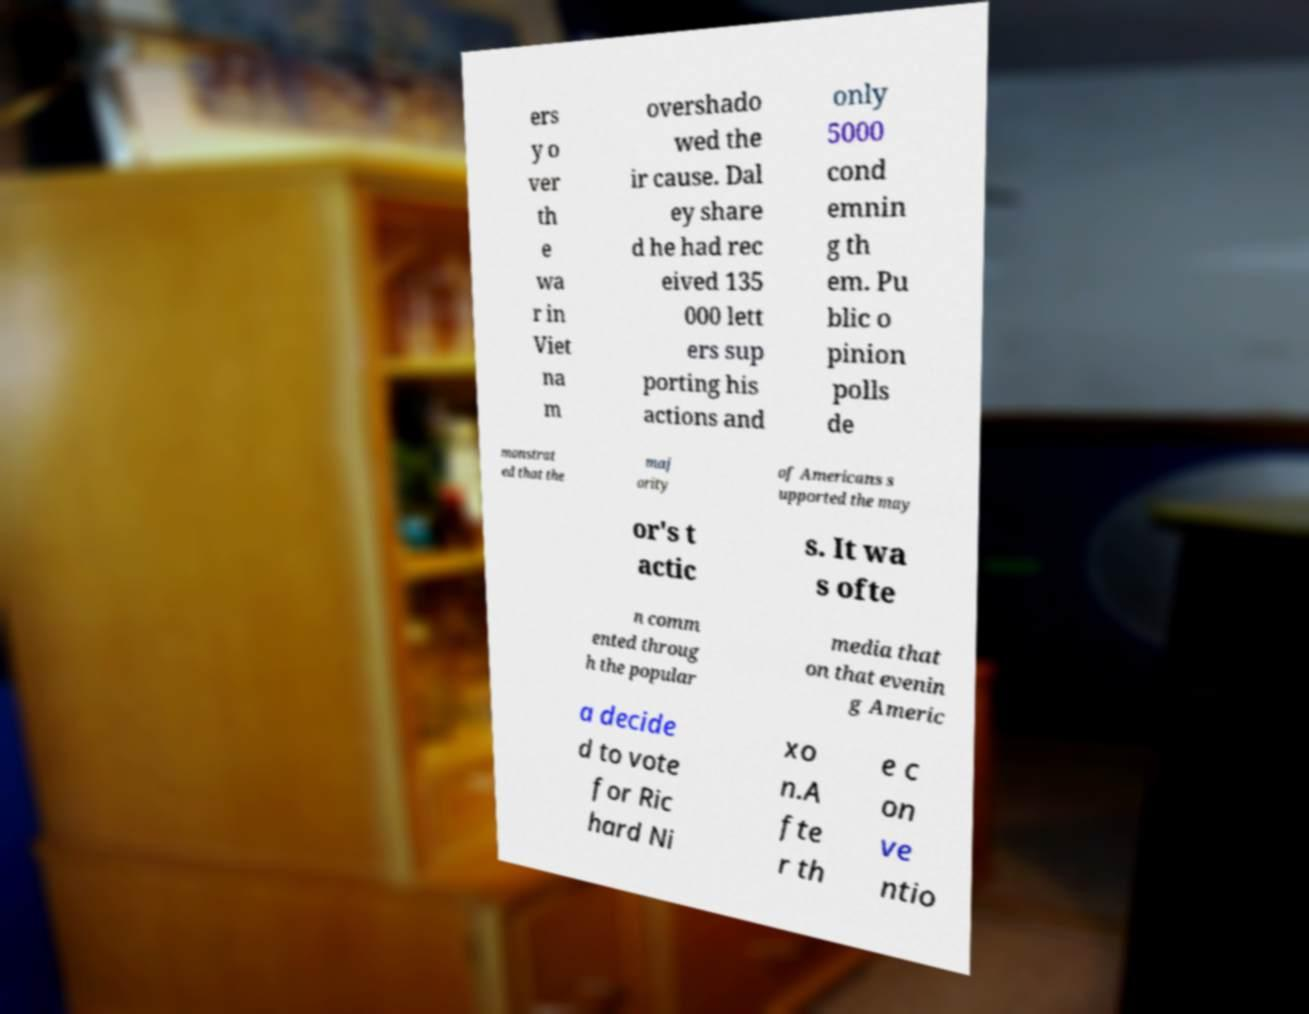Please read and relay the text visible in this image. What does it say? ers y o ver th e wa r in Viet na m overshado wed the ir cause. Dal ey share d he had rec eived 135 000 lett ers sup porting his actions and only 5000 cond emnin g th em. Pu blic o pinion polls de monstrat ed that the maj ority of Americans s upported the may or's t actic s. It wa s ofte n comm ented throug h the popular media that on that evenin g Americ a decide d to vote for Ric hard Ni xo n.A fte r th e c on ve ntio 